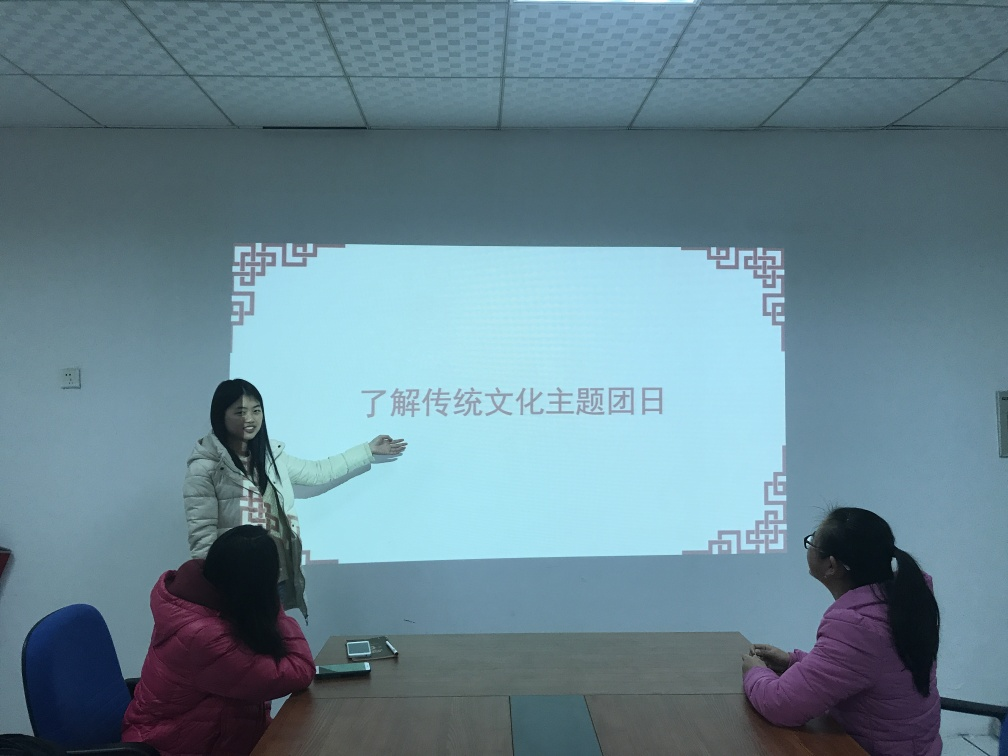What is the woman in the image doing? The woman appears to be presenting or lecturing, as indicated by her gesture towards the projection screen and her open, communicative body language. How do the audience members seem to be reacting? The audience members, although not fully visible, appear to be attentive. One person is seated with their head angled towards the presenter, indicating that they are following the presentation. 